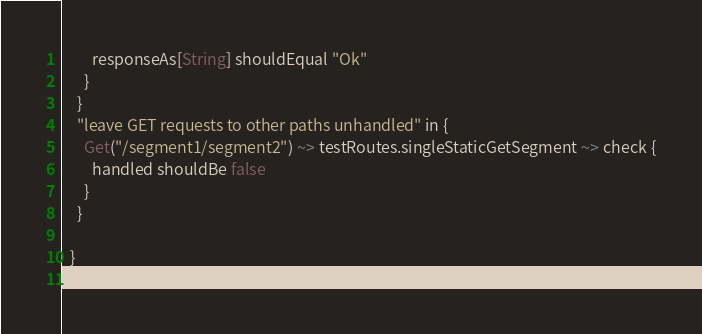<code> <loc_0><loc_0><loc_500><loc_500><_Scala_>        responseAs[String] shouldEqual "Ok"
      }
    }
    "leave GET requests to other paths unhandled" in {
      Get("/segment1/segment2") ~> testRoutes.singleStaticGetSegment ~> check {
        handled shouldBe false
      }
    }

  }
}
</code> 